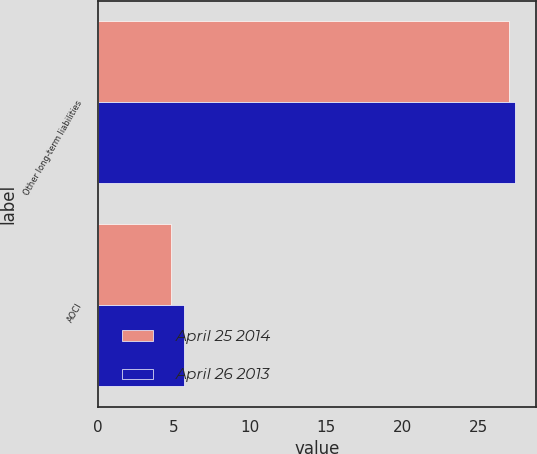Convert chart to OTSL. <chart><loc_0><loc_0><loc_500><loc_500><stacked_bar_chart><ecel><fcel>Other long-term liabilities<fcel>AOCI<nl><fcel>April 25 2014<fcel>27<fcel>4.8<nl><fcel>April 26 2013<fcel>27.4<fcel>5.7<nl></chart> 